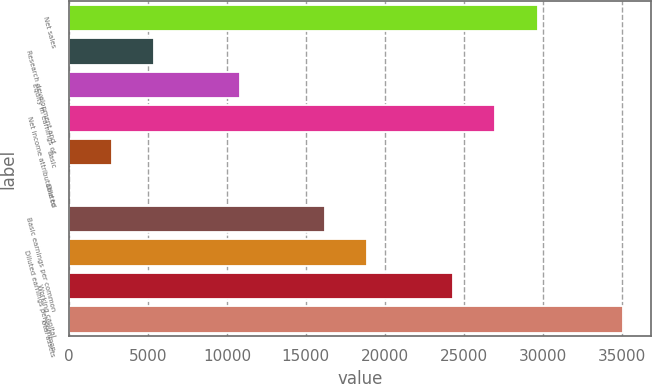Convert chart to OTSL. <chart><loc_0><loc_0><loc_500><loc_500><bar_chart><fcel>Net sales<fcel>Research development and<fcel>Equity in earnings of<fcel>Net income attributable to<fcel>Basic<fcel>Diluted<fcel>Basic earnings per common<fcel>Diluted earnings per common<fcel>Working capital<fcel>Total assets<nl><fcel>29699.7<fcel>5402.66<fcel>10802<fcel>27000<fcel>2702.99<fcel>3.32<fcel>16201.3<fcel>18901<fcel>24300.3<fcel>35099<nl></chart> 